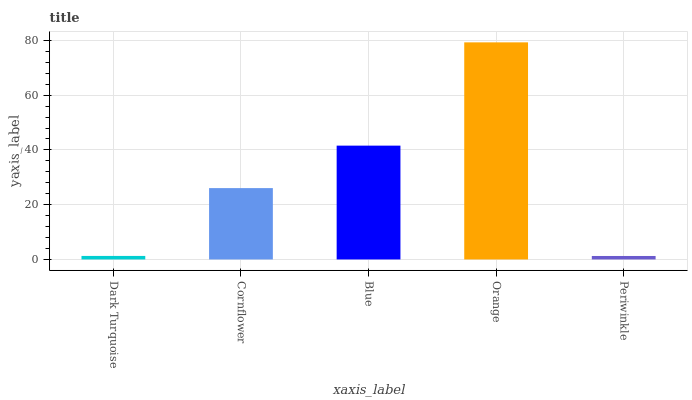Is Periwinkle the minimum?
Answer yes or no. Yes. Is Orange the maximum?
Answer yes or no. Yes. Is Cornflower the minimum?
Answer yes or no. No. Is Cornflower the maximum?
Answer yes or no. No. Is Cornflower greater than Dark Turquoise?
Answer yes or no. Yes. Is Dark Turquoise less than Cornflower?
Answer yes or no. Yes. Is Dark Turquoise greater than Cornflower?
Answer yes or no. No. Is Cornflower less than Dark Turquoise?
Answer yes or no. No. Is Cornflower the high median?
Answer yes or no. Yes. Is Cornflower the low median?
Answer yes or no. Yes. Is Orange the high median?
Answer yes or no. No. Is Blue the low median?
Answer yes or no. No. 